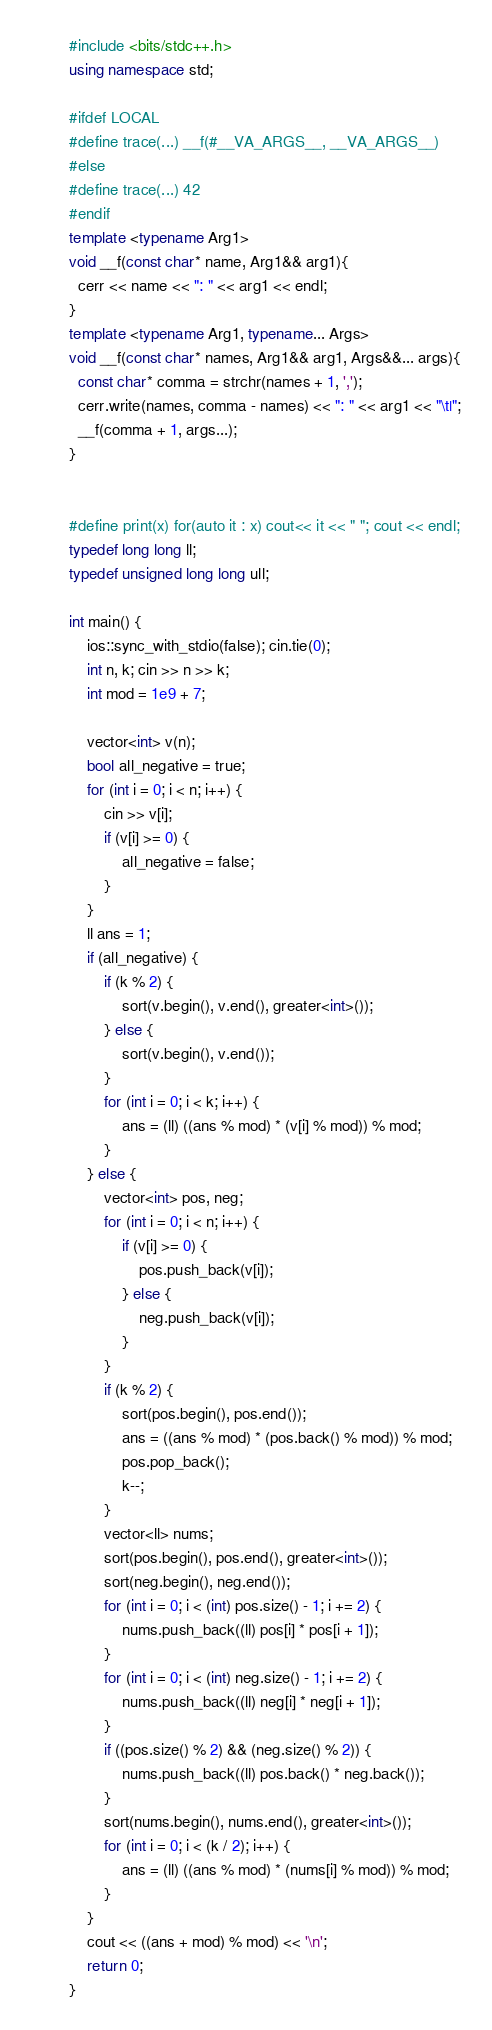<code> <loc_0><loc_0><loc_500><loc_500><_C++_>#include <bits/stdc++.h>
using namespace std;

#ifdef LOCAL
#define trace(...) __f(#__VA_ARGS__, __VA_ARGS__)
#else
#define trace(...) 42
#endif
template <typename Arg1>
void __f(const char* name, Arg1&& arg1){
  cerr << name << ": " << arg1 << endl;
}
template <typename Arg1, typename... Args>
void __f(const char* names, Arg1&& arg1, Args&&... args){
  const char* comma = strchr(names + 1, ',');
  cerr.write(names, comma - names) << ": " << arg1 << "\t|";
  __f(comma + 1, args...);
}
 

#define print(x) for(auto it : x) cout<< it << " "; cout << endl;
typedef long long ll;
typedef unsigned long long ull;

int main() {
    ios::sync_with_stdio(false); cin.tie(0);
    int n, k; cin >> n >> k;
    int mod = 1e9 + 7;
    
    vector<int> v(n);
    bool all_negative = true;
    for (int i = 0; i < n; i++) {
        cin >> v[i];
        if (v[i] >= 0) {
            all_negative = false;
        }
    }
    ll ans = 1;
    if (all_negative) {
        if (k % 2) {
            sort(v.begin(), v.end(), greater<int>());
        } else {
            sort(v.begin(), v.end());
        }
        for (int i = 0; i < k; i++) {
            ans = (ll) ((ans % mod) * (v[i] % mod)) % mod;
        }
    } else {
        vector<int> pos, neg;
        for (int i = 0; i < n; i++) {
            if (v[i] >= 0) {
                pos.push_back(v[i]);
            } else {
                neg.push_back(v[i]);
            }
        }
        if (k % 2) {
            sort(pos.begin(), pos.end());
            ans = ((ans % mod) * (pos.back() % mod)) % mod;
            pos.pop_back();
            k--;
        }
        vector<ll> nums;
        sort(pos.begin(), pos.end(), greater<int>());
        sort(neg.begin(), neg.end());
        for (int i = 0; i < (int) pos.size() - 1; i += 2) {
            nums.push_back((ll) pos[i] * pos[i + 1]);
        }
        for (int i = 0; i < (int) neg.size() - 1; i += 2) {
            nums.push_back((ll) neg[i] * neg[i + 1]);
        }
        if ((pos.size() % 2) && (neg.size() % 2)) {
            nums.push_back((ll) pos.back() * neg.back());
        }
        sort(nums.begin(), nums.end(), greater<int>());
        for (int i = 0; i < (k / 2); i++) {
            ans = (ll) ((ans % mod) * (nums[i] % mod)) % mod;
        }
    }
    cout << ((ans + mod) % mod) << '\n';
    return 0;
}
</code> 